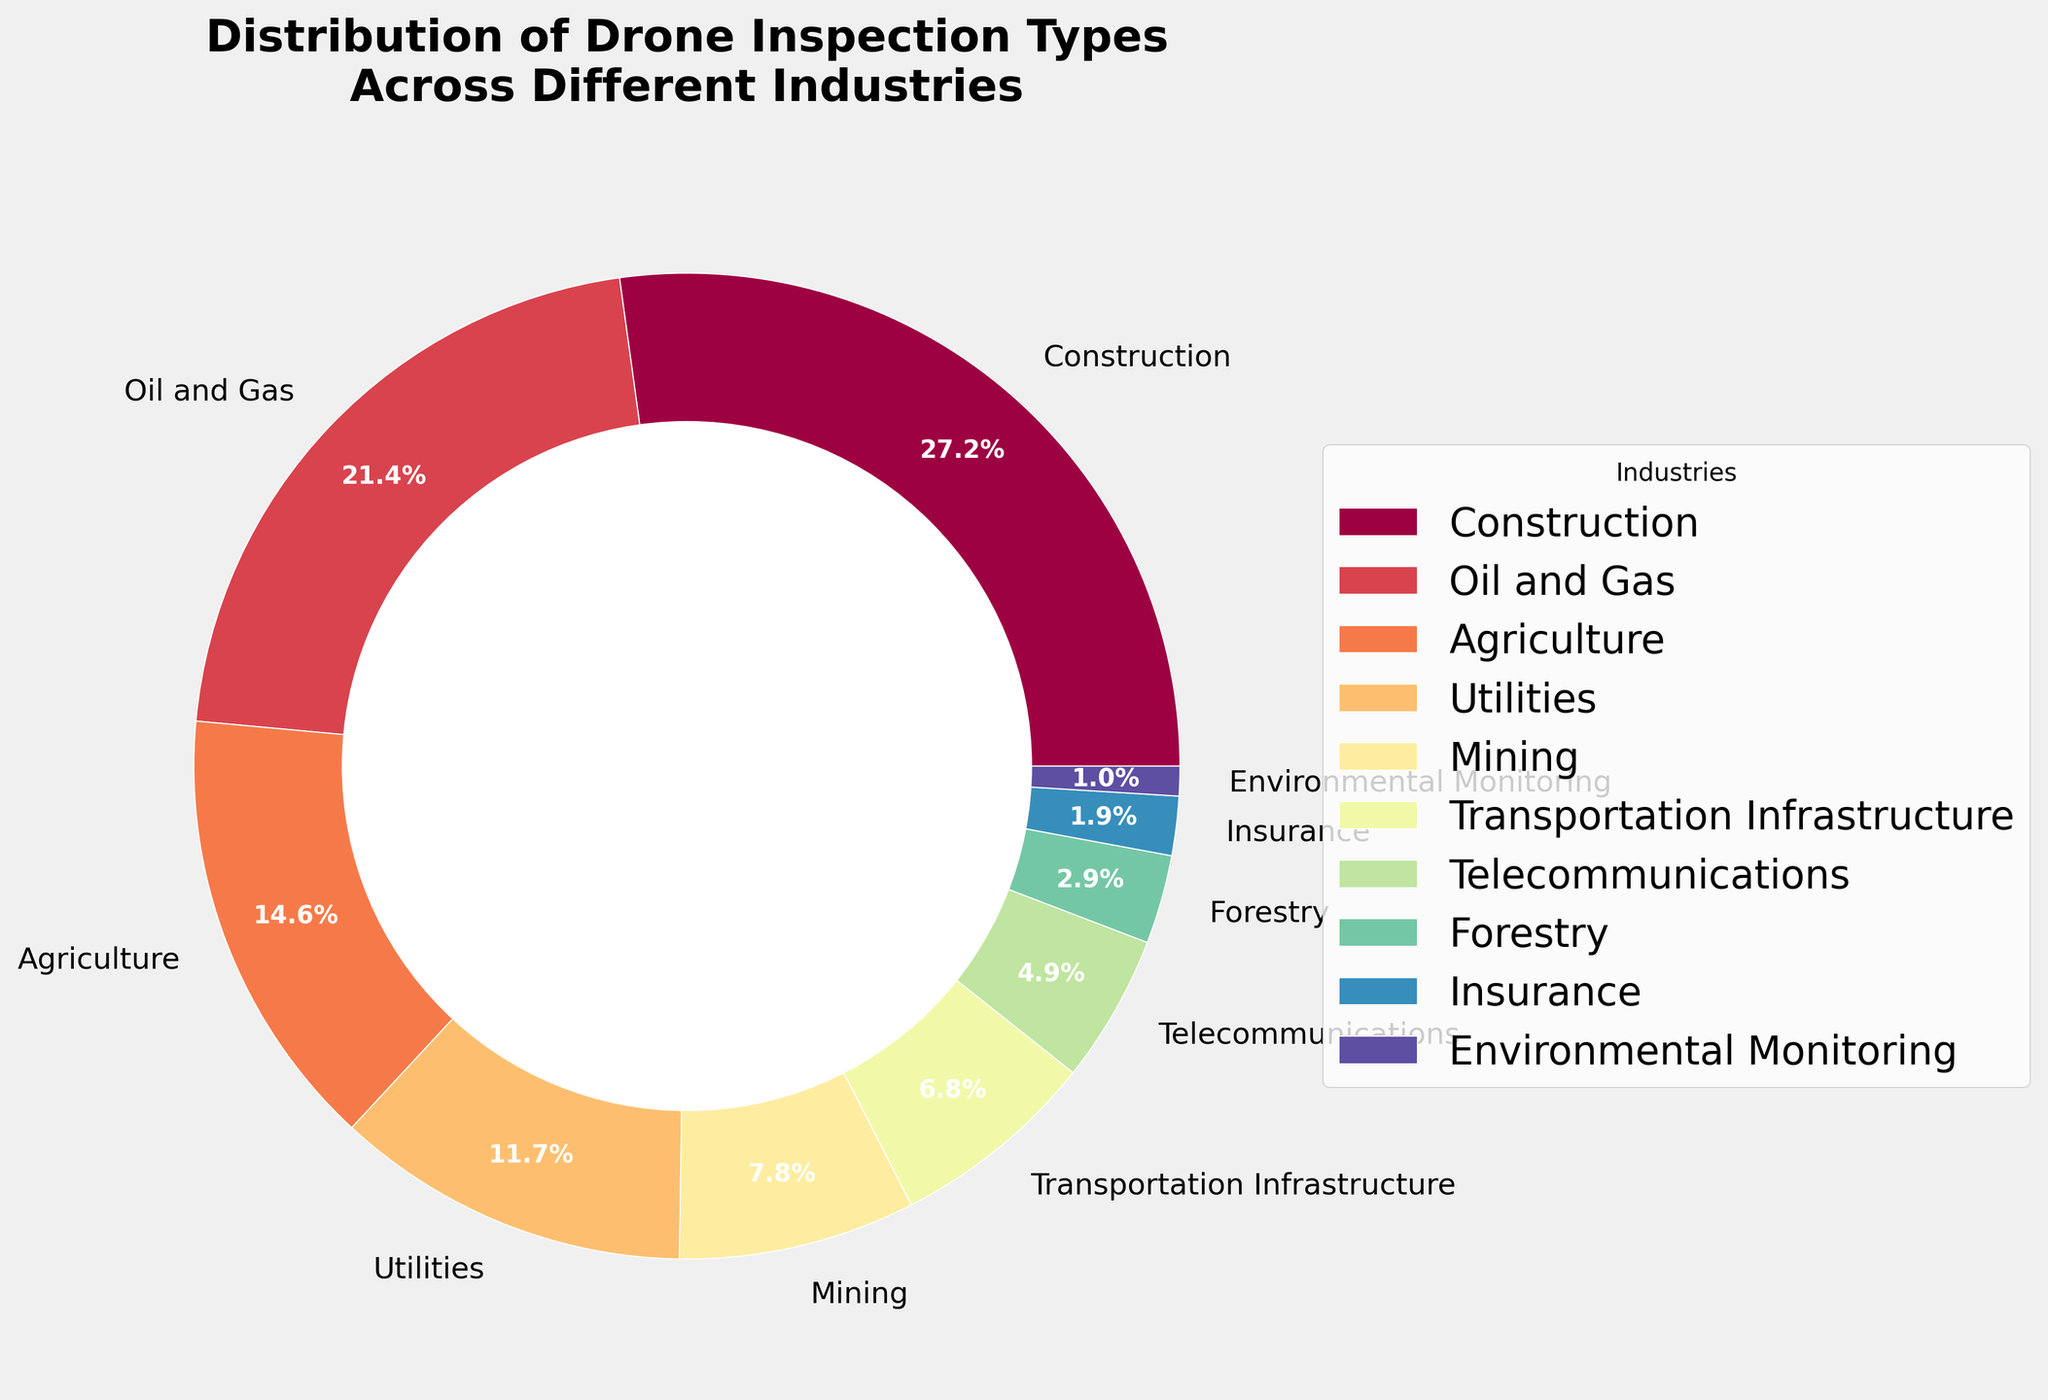Which industry has the highest percentage of drone inspections? By inspecting the pie chart, the segment that occupies the largest area corresponds to "Construction" with 28%.
Answer: Construction What is the combined percentage of drone inspections for Agriculture and Utilities? Find the slices for "Agriculture" and "Utilities" on the pie chart and add their percentages: 15% + 12% = 27%.
Answer: 27% Which industry has a lower percentage of drone inspections, Mining or Telecommunications? Compare the segments for "Mining" and "Telecommunications". Mining has 8%, while Telecommunications has 5%. Therefore, Telecommunications has a lower percentage.
Answer: Telecommunications What is the percentage difference between Oil and Gas and Transportation Infrastructure? Find the slices for "Oil and Gas" and "Transportation Infrastructure" and subtract the smaller percentage from the larger one: 22% - 7% = 15%.
Answer: 15% How many industries have a percentage lower than 10%? Identify the segments in the pie chart with percentages less than 10%: Mining (8%), Transportation Infrastructure (7%), Telecommunications (5%), Forestry (3%), Insurance (2%), Environmental Monitoring (1%). There are 6 such industries.
Answer: 6 Is the sum of the percentages of Forestry, Insurance, and Environmental Monitoring greater than the percentage for Agriculture? Add the percentages for Forestry, Insurance, and Environmental Monitoring first: 3% + 2% + 1% = 6%. Compare this to Agriculture's percentage, which is 15%. 6% is less than 15%.
Answer: No Which industry is represented by the smallest segment of the pie chart? The smallest slice of the pie chart corresponds to "Environmental Monitoring" with 1%.
Answer: Environmental Monitoring What is the percentage range of the drone inspections among the listed industries? The minimum percentage is for Environmental Monitoring with 1%, and the maximum is for Construction with 28%. Compute the range: 28% - 1% = 27%.
Answer: 27% How does the percentage of drone inspections in Construction compare to that in Oil and Gas? Compare the segments for "Construction" and "Oil and Gas". Construction has 28% and Oil and Gas has 22%. Construction has a higher percentage.
Answer: Construction has a higher percentage 